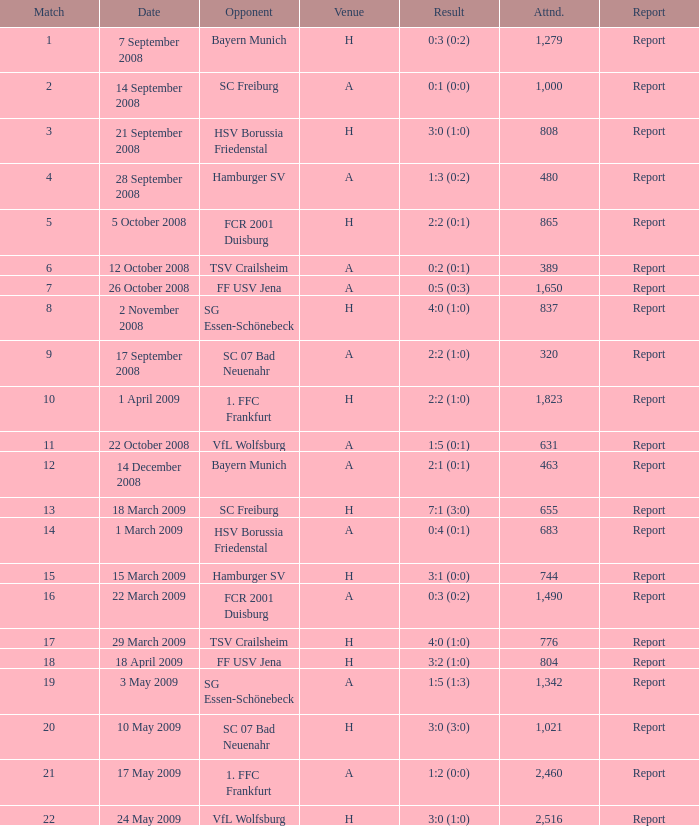Which match did FCR 2001 Duisburg participate as the opponent? 21.0. 